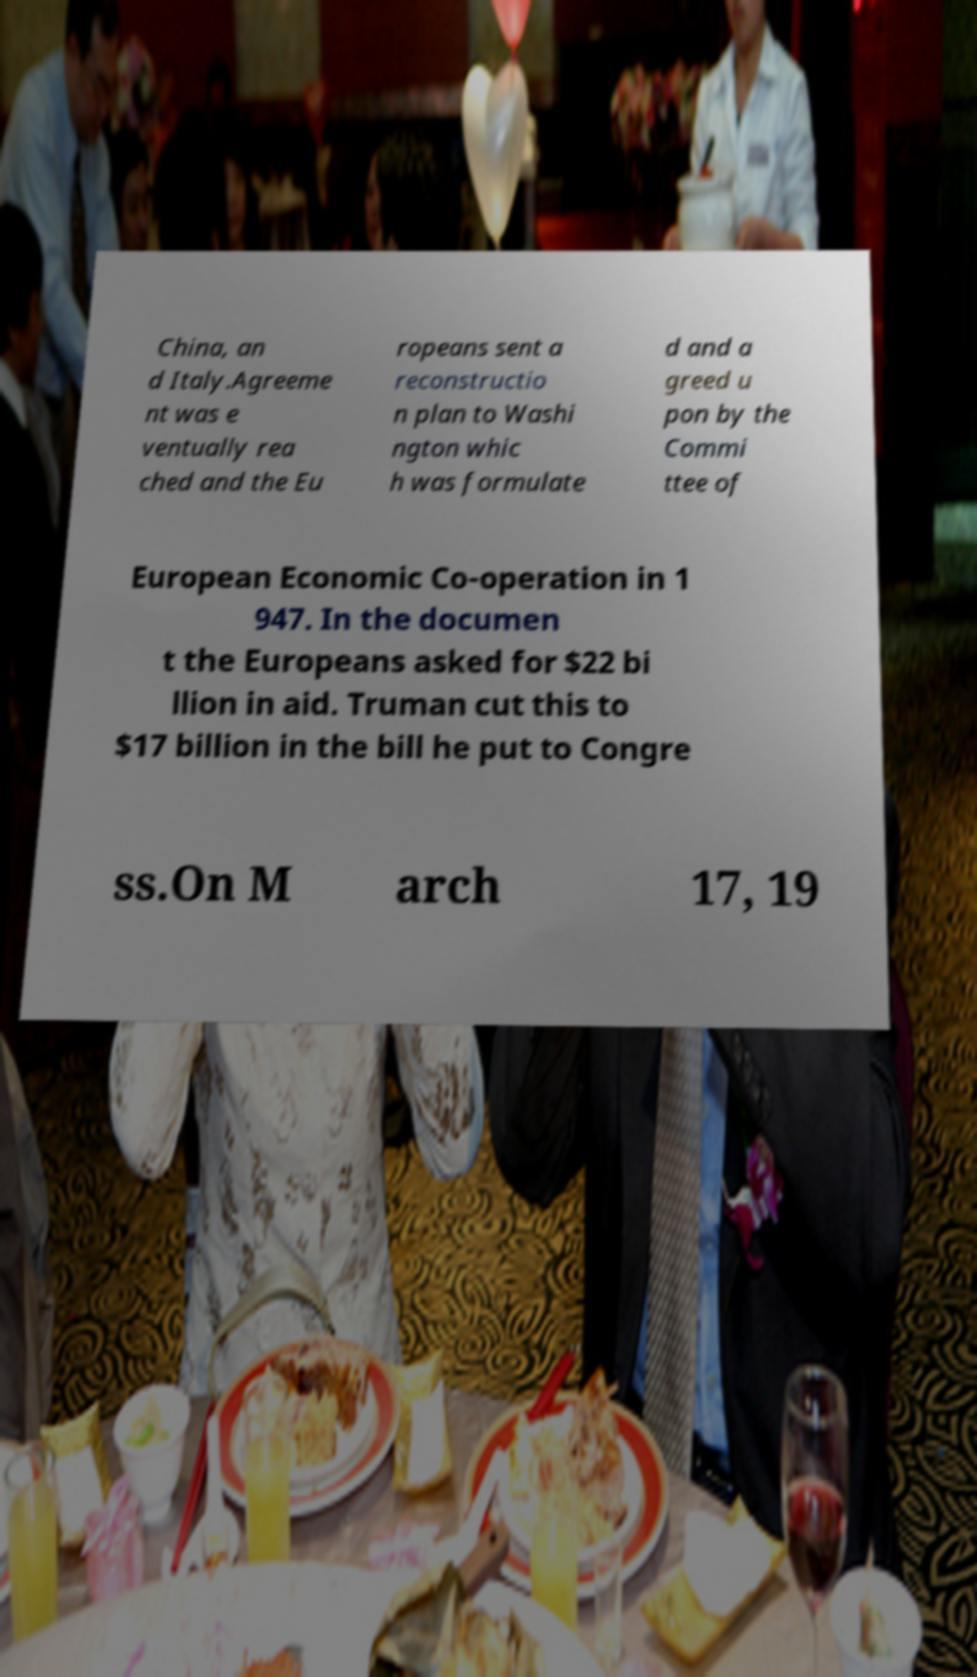I need the written content from this picture converted into text. Can you do that? China, an d Italy.Agreeme nt was e ventually rea ched and the Eu ropeans sent a reconstructio n plan to Washi ngton whic h was formulate d and a greed u pon by the Commi ttee of European Economic Co-operation in 1 947. In the documen t the Europeans asked for $22 bi llion in aid. Truman cut this to $17 billion in the bill he put to Congre ss.On M arch 17, 19 